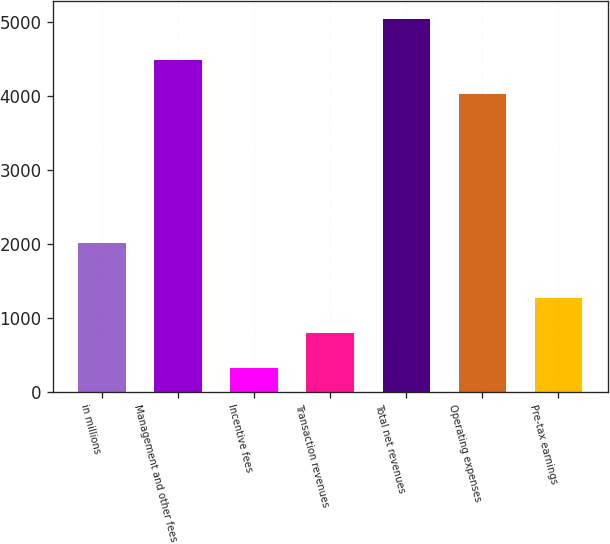Convert chart to OTSL. <chart><loc_0><loc_0><loc_500><loc_500><bar_chart><fcel>in millions<fcel>Management and other fees<fcel>Incentive fees<fcel>Transaction revenues<fcel>Total net revenues<fcel>Operating expenses<fcel>Pre-tax earnings<nl><fcel>2011<fcel>4491.1<fcel>323<fcel>794.1<fcel>5034<fcel>4020<fcel>1265.2<nl></chart> 